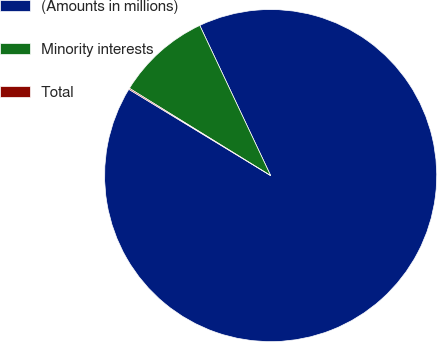Convert chart. <chart><loc_0><loc_0><loc_500><loc_500><pie_chart><fcel>(Amounts in millions)<fcel>Minority interests<fcel>Total<nl><fcel>90.71%<fcel>9.17%<fcel>0.11%<nl></chart> 